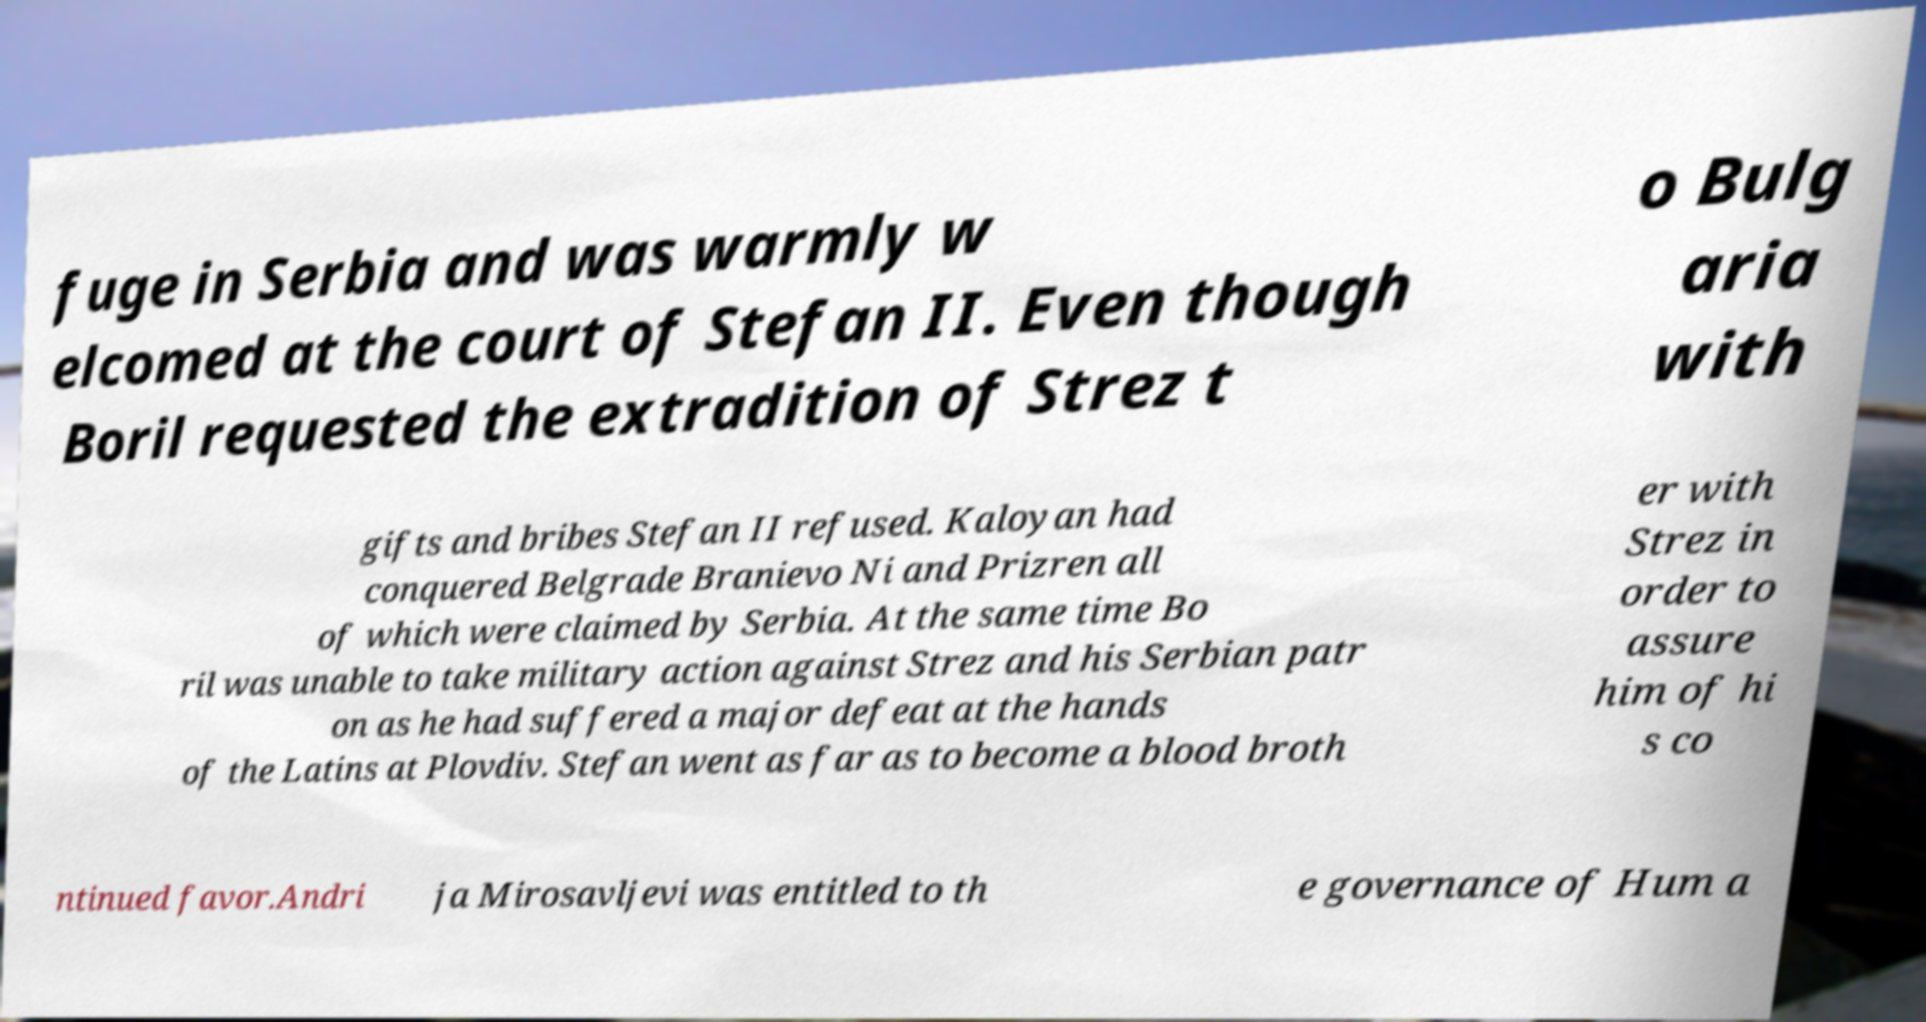Can you read and provide the text displayed in the image?This photo seems to have some interesting text. Can you extract and type it out for me? fuge in Serbia and was warmly w elcomed at the court of Stefan II. Even though Boril requested the extradition of Strez t o Bulg aria with gifts and bribes Stefan II refused. Kaloyan had conquered Belgrade Branievo Ni and Prizren all of which were claimed by Serbia. At the same time Bo ril was unable to take military action against Strez and his Serbian patr on as he had suffered a major defeat at the hands of the Latins at Plovdiv. Stefan went as far as to become a blood broth er with Strez in order to assure him of hi s co ntinued favor.Andri ja Mirosavljevi was entitled to th e governance of Hum a 